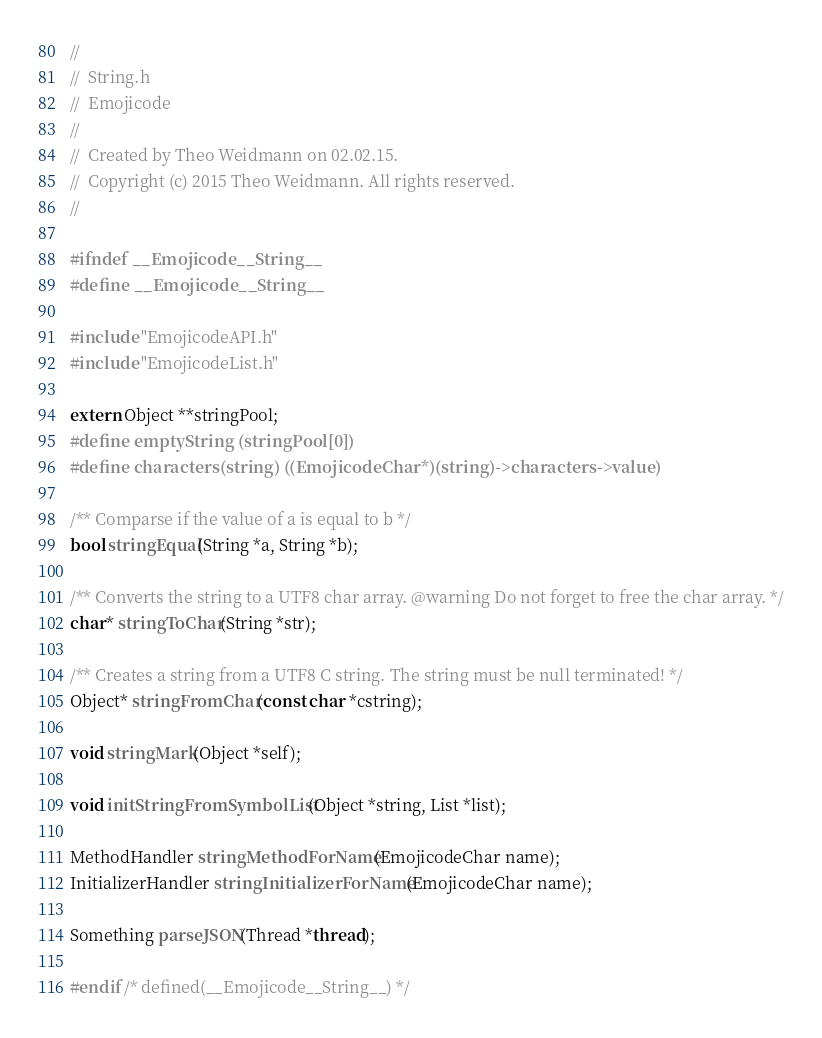Convert code to text. <code><loc_0><loc_0><loc_500><loc_500><_C_>//
//  String.h
//  Emojicode
//
//  Created by Theo Weidmann on 02.02.15.
//  Copyright (c) 2015 Theo Weidmann. All rights reserved.
//

#ifndef __Emojicode__String__
#define __Emojicode__String__

#include "EmojicodeAPI.h"
#include "EmojicodeList.h"

extern Object **stringPool;
#define emptyString (stringPool[0])
#define characters(string) ((EmojicodeChar*)(string)->characters->value)

/** Comparse if the value of a is equal to b */
bool stringEqual(String *a, String *b);

/** Converts the string to a UTF8 char array. @warning Do not forget to free the char array. */
char* stringToChar(String *str);

/** Creates a string from a UTF8 C string. The string must be null terminated! */
Object* stringFromChar(const char *cstring);

void stringMark(Object *self);

void initStringFromSymbolList(Object *string, List *list);

MethodHandler stringMethodForName(EmojicodeChar name);
InitializerHandler stringInitializerForName(EmojicodeChar name);

Something parseJSON(Thread *thread);

#endif /* defined(__Emojicode__String__) */
</code> 